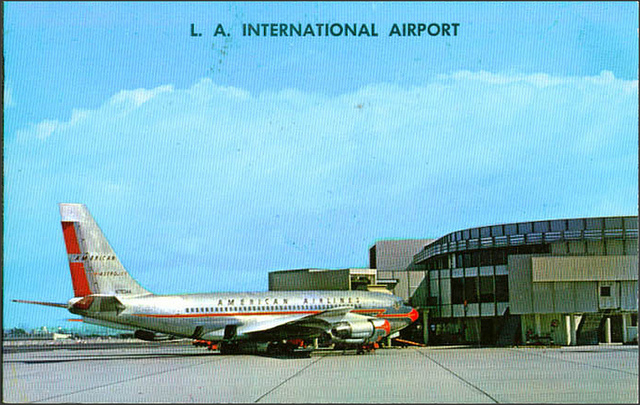<image>What airport is this? I don't know which airport this is. It could be LA International Airport, Dulles, or Port Columbus. What airline's plane is in the photo? I am not sure which airline's plane is in the photo. It might be American Airlines. What airport is this? I am not sure what airport this is. It could be LA International Airport or Port Columbus. What airline's plane is in the photo? The plane in the photo belongs to American Airlines. 